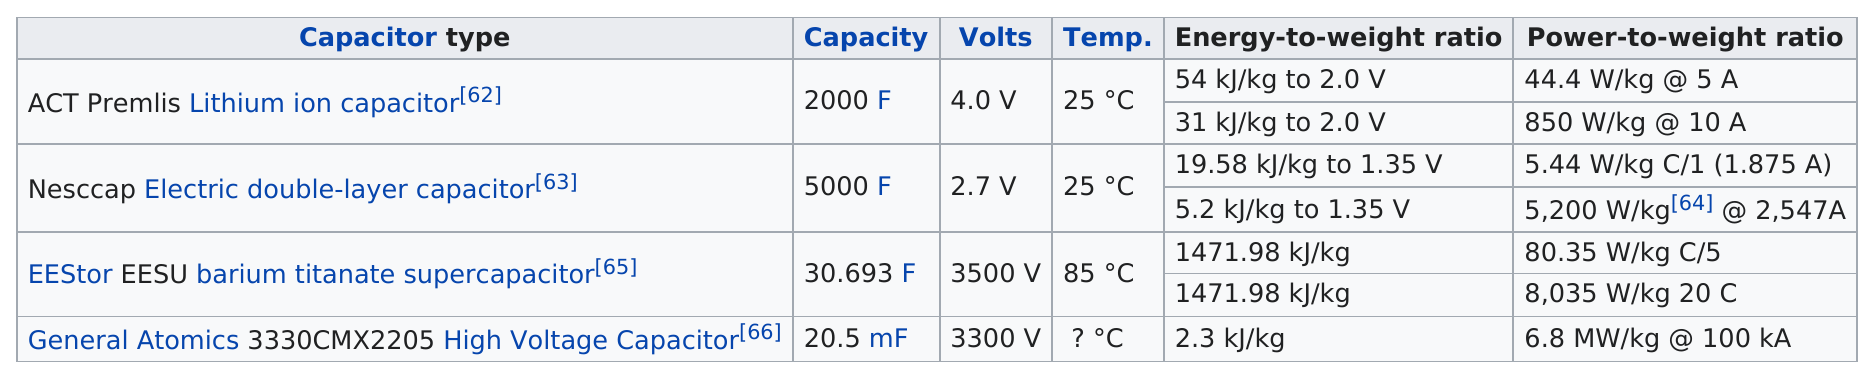Give some essential details in this illustration. The next value after 2.7 volts is 3500 volts. The Nesscap Electric double-layer capacitor is below the act. The average temperature of a NESCAP electric double-layer capacitor is 25 degrees Celsius. The ACT Premlis Lithium ion capacitor has the same temperature as the NESCAP Electric Double-Layer Capacitor. The Nescap Electric double-layer capacitor is the only capacitor with a capacity of at least 3000 farads (f). 